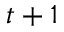<formula> <loc_0><loc_0><loc_500><loc_500>t + 1</formula> 